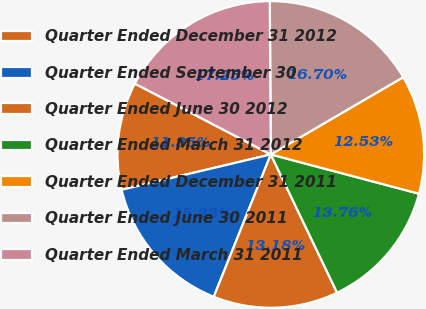<chart> <loc_0><loc_0><loc_500><loc_500><pie_chart><fcel>Quarter Ended December 31 2012<fcel>Quarter Ended September 30<fcel>Quarter Ended June 30 2012<fcel>Quarter Ended March 31 2012<fcel>Quarter Ended December 31 2011<fcel>Quarter Ended June 30 2011<fcel>Quarter Ended March 31 2011<nl><fcel>11.35%<fcel>15.23%<fcel>13.18%<fcel>13.76%<fcel>12.53%<fcel>16.7%<fcel>17.25%<nl></chart> 